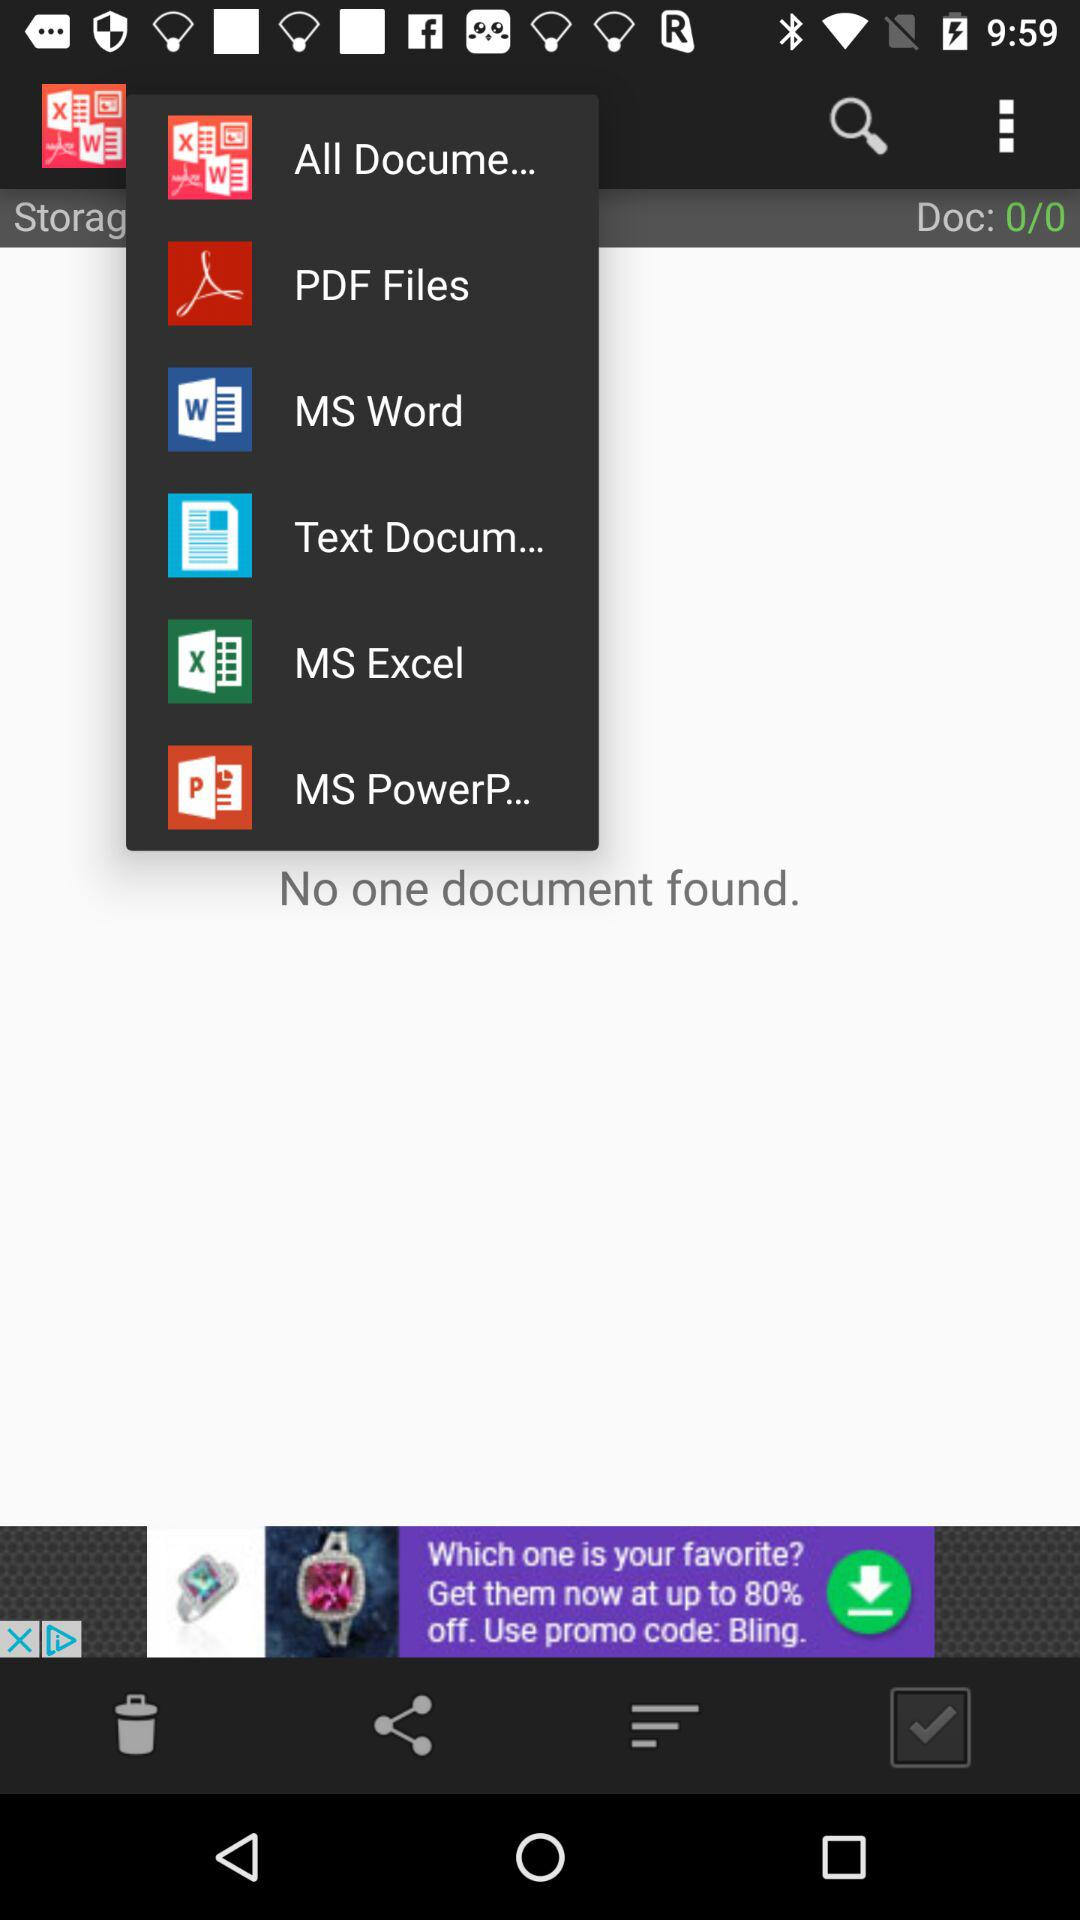How many documents were found? There were no documents found. 